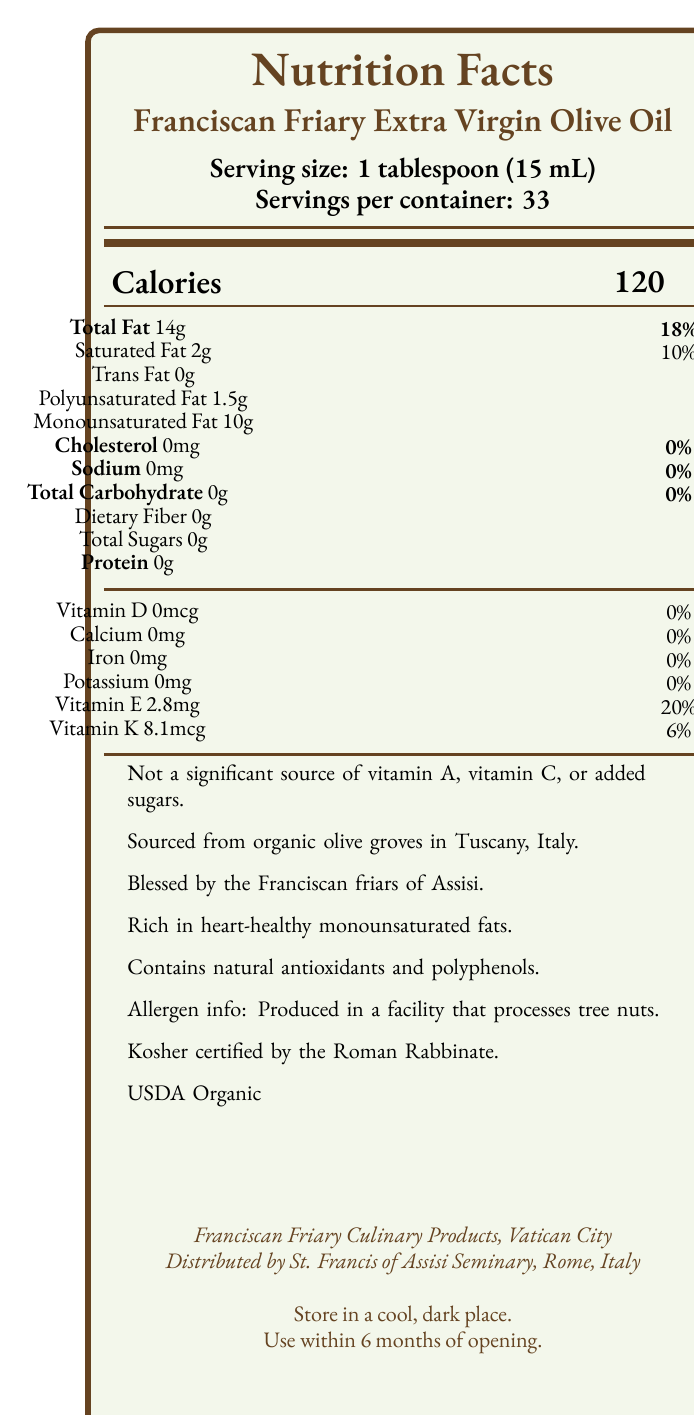what is the calories per serving? The document states that each serving size of 1 tablespoon (15 mL) of the olive oil contains 120 calories.
Answer: 120 how much total fat is in one serving and what percentage of the daily value does it represent? The document mentions that each serving contains 14 grams of total fat, which represents 18% of the daily value.
Answer: 14g, 18% does the product contain any cholesterol? The document specifies that the product contains 0mg of cholesterol.
Answer: No which vitamins are present in this olive oil and in what amounts? The document lists Vitamin E at 2.8mg and Vitamin K at 8.1mcg per serving.
Answer: Vitamin E: 2.8mg, Vitamin K: 8.1mcg what is the storage recommendation for this product? The document provides a storage instruction to keep the product in a cool, dark place and to use it within 6 months of opening.
Answer: Store in a cool, dark place. Use within 6 months of opening. what type of facility is the product produced in? A. A dairy facility B. A facility that processes tree nuts C. A gluten-free facility D. A seafood processing facility The document states that the product is produced in a facility that processes tree nuts.
Answer: B which of the following is a use suggested for this olive oil? i. Dressing salads ii. Stir-frying iii. Baking bread iv. Dressing wounds Among the usage suggestions listed, dressing salads is mentioned as an ideal use for this olive oil.
Answer: i. Dressing salads is the olive oil certified Kosher? The document confirms that the olive oil is Kosher certified by the Roman Rabbinate.
Answer: Yes summarize the main idea of the Nutrition Facts Label for Franciscan Friary Extra Virgin Olive Oil. The document provides comprehensive information about the product, including its nutritional values, vitamins, organic and Kosher certifications, allergen information, usage suggestions, and storage instructions.
Answer: The Nutrition Facts Label details the serving size, nutritional content, vitamins, additional product information, allergen information, certifications, usage suggestions, storage instructions, and manufacturer details of Franciscan Friary Extra Virgin Olive Oil. does the product contain any significant source of vitamin A, vitamin C, or added sugars? The document explicitly mentions that it is not a significant source of vitamin A, vitamin C, or added sugars.
Answer: No what is the origin of the olives used to make this olive oil? The document does not provide specific information regarding the origin of the olives used in the olive oil.
Answer: Cannot be determined 